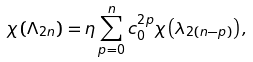Convert formula to latex. <formula><loc_0><loc_0><loc_500><loc_500>\chi \left ( \Lambda _ { 2 n } \right ) = \eta \sum _ { p = 0 } ^ { n } c ^ { 2 p } _ { 0 } \chi \left ( \lambda _ { 2 ( n - p ) } \right ) ,</formula> 